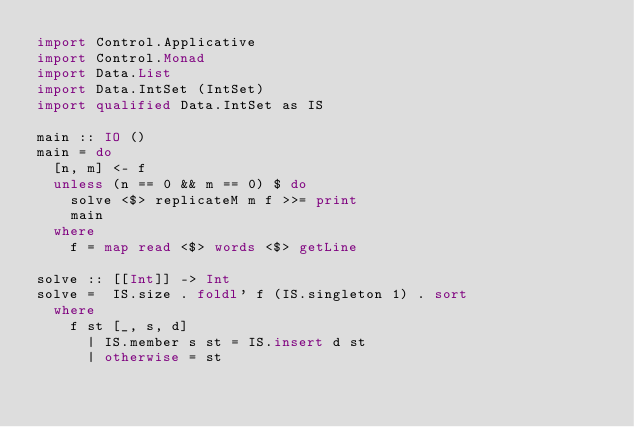Convert code to text. <code><loc_0><loc_0><loc_500><loc_500><_Haskell_>import Control.Applicative
import Control.Monad
import Data.List
import Data.IntSet (IntSet)
import qualified Data.IntSet as IS

main :: IO ()
main = do
  [n, m] <- f
  unless (n == 0 && m == 0) $ do
    solve <$> replicateM m f >>= print
    main
  where
    f = map read <$> words <$> getLine

solve :: [[Int]] -> Int
solve =  IS.size . foldl' f (IS.singleton 1) . sort
  where
    f st [_, s, d]
      | IS.member s st = IS.insert d st
      | otherwise = st

</code> 